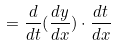<formula> <loc_0><loc_0><loc_500><loc_500>= \frac { d } { d t } ( \frac { d y } { d x } ) \cdot \frac { d t } { d x }</formula> 